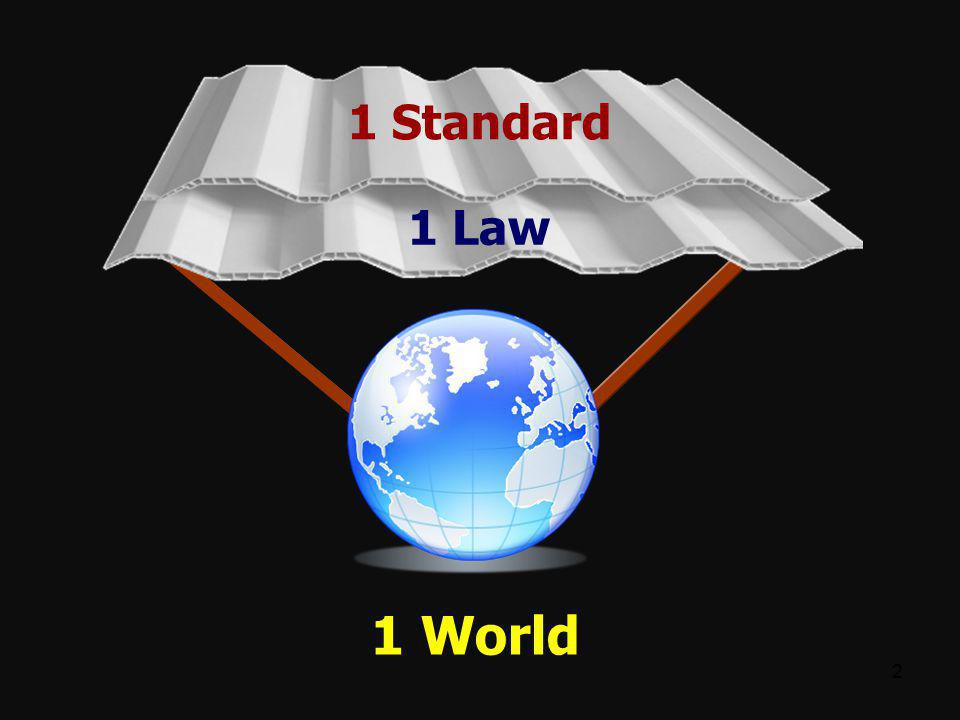What could the significance of the number "2" in the bottom right corner imply in the context of this image? The number "2" in the bottom right corner likely signifies that this image is part of a sequence, such as the second slide in a presentation or the second image in a series. This suggests that there is additional content that provides context or follows this image. The image itself depicts a unified world supported by the concepts of one standard and one law, implying a message of global unity and coherence that may be elaborated upon in the preceding or subsequent slides. 